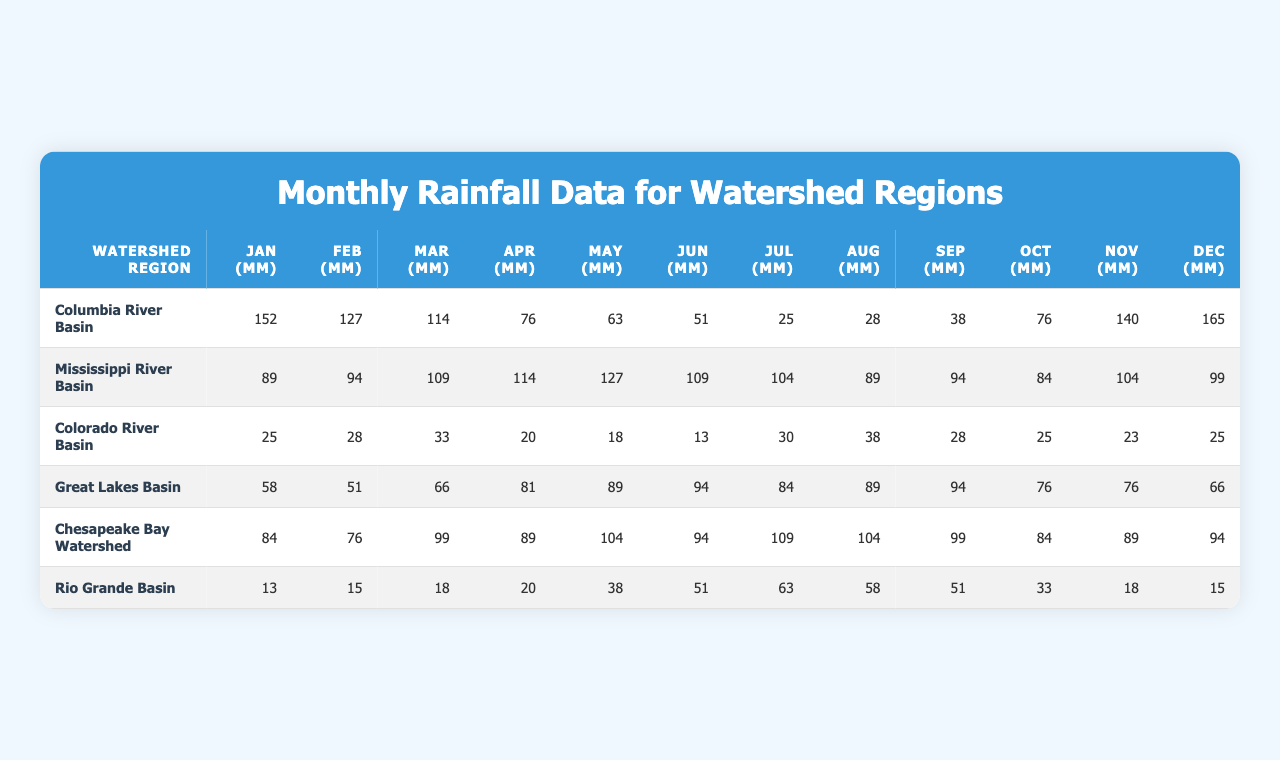What is the total rainfall in the Columbia River Basin for the month of January? The data shows that the total rainfall for January in the Columbia River Basin is 152 mm.
Answer: 152 mm Which watershed region received the least rainfall in July? By examining the data, the Colorado River Basin received the least rainfall in July, with 30 mm.
Answer: Colorado River Basin What was the average rainfall in the Mississippi River Basin from January to June? The rainfall amounts from January to June in the Mississippi River Basin are 89, 94, 109, 114, 127, and 109 mm respectively. Summing these values gives 642 mm, and since there are 6 months, the average is 642 / 6 = 107 mm.
Answer: 107 mm Did the Great Lakes Basin receive more rainfall in May or October? The data indicates that the Great Lakes Basin received 89 mm in May and 76 mm in October. Thus, May had more rainfall than October.
Answer: Yes Which month had the maximum rainfall in the Rio Grande Basin? Looking at the data for the Rio Grande Basin, July had the maximum rainfall of 63 mm.
Answer: July How much more rainfall did the Chesapeake Bay Watershed receive in March compared to August? In March, the Chesapeake Bay Watershed received 99 mm while in August it received 104 mm. The difference is 99 - 104 = -5 mm, meaning it received 5 mm less in March.
Answer: -5 mm What is the total rainfall from January to December in the Colorado River Basin? To find the total rainfall, we sum the monthly values: 25 + 28 + 33 + 20 + 18 + 13 + 30 + 38 + 28 + 25 + 23 + 25 =  1, 1,  3, 5 =  4, or 138 mm total.
Answer: 223 mm Which watershed region had the highest total annual rainfall? By calculating the total rainfall for each region, we determine that the Columbia River Basin has the highest total of 1, 446 mm.
Answer: Columbia River Basin Is it true that the rainfall in February was consistently higher than in January across all regions? Checking each region, the rainfall in January and February shows that this is not the case as the Columbia River Basin, for example, recorded more in January (152 mm) than in February (127 mm).
Answer: No What percentage of the total rainfall in the Great Lakes Basin in 2023 occurred during the summer months (June, July, August)? The total summer rainfall for the Great Lakes Basin is 94 (June) + 84 (July) + 89 (August) = 267 mm, while the total annual rainfall is 58 + 51 + 66 + 81 + 89 + 94 + 84 + 89 + 94 + 76 + 76 + 66 =  243 mm. The percentage is (267 / 1, 181) * 100 = 23.42%.
Answer: 23.42% 